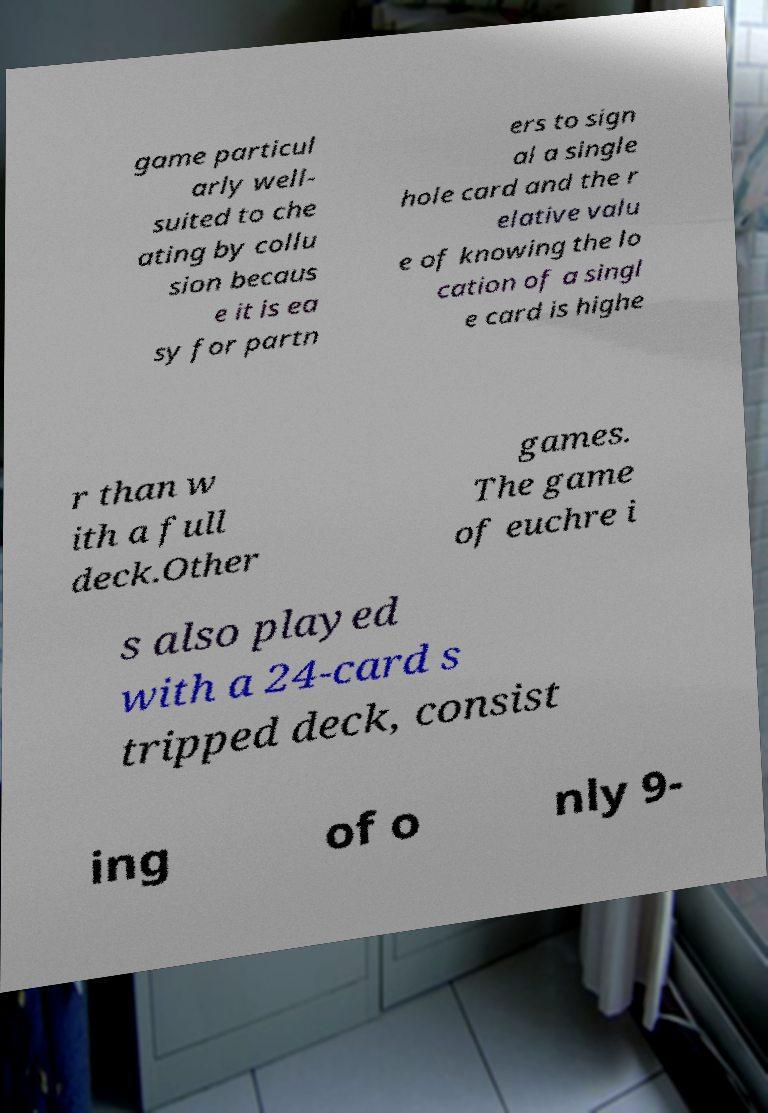Could you assist in decoding the text presented in this image and type it out clearly? game particul arly well- suited to che ating by collu sion becaus e it is ea sy for partn ers to sign al a single hole card and the r elative valu e of knowing the lo cation of a singl e card is highe r than w ith a full deck.Other games. The game of euchre i s also played with a 24-card s tripped deck, consist ing of o nly 9- 